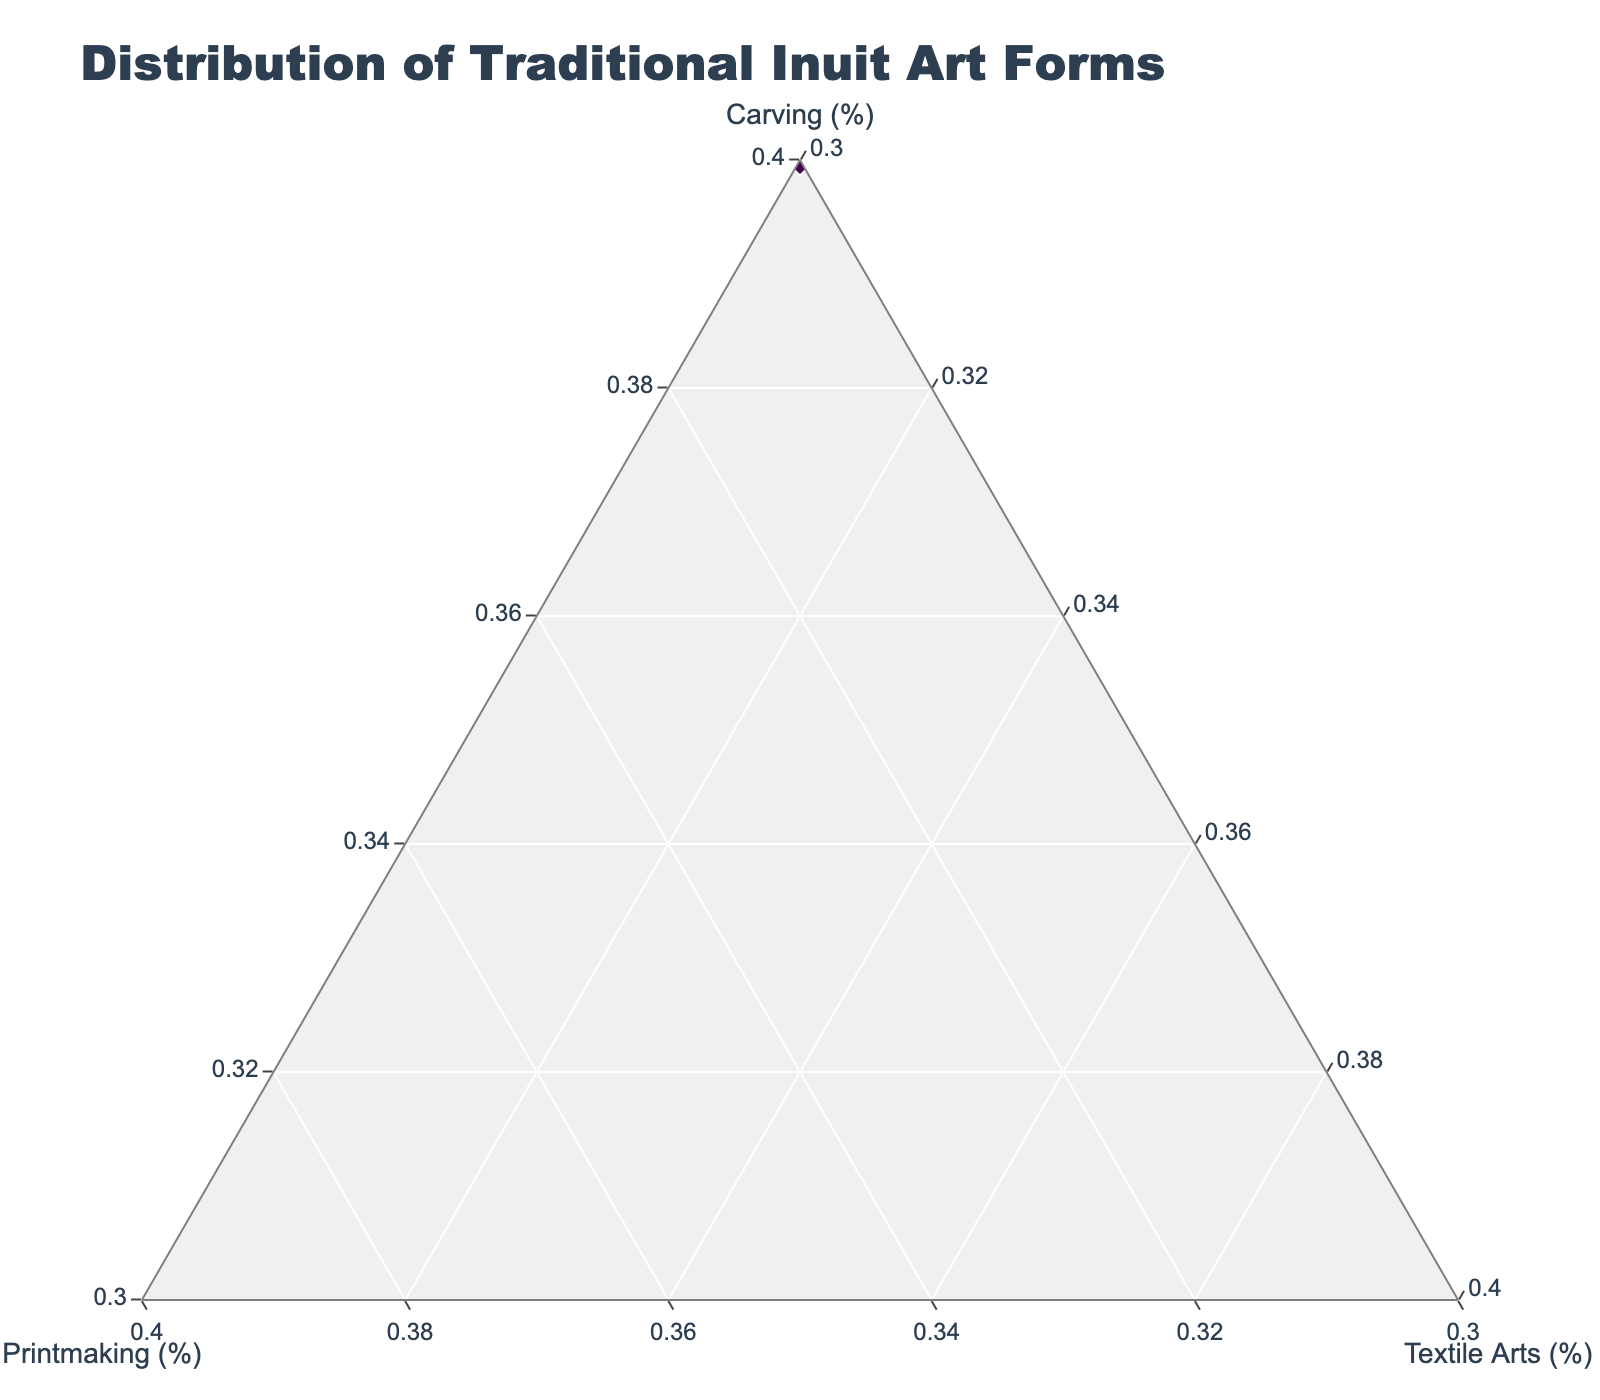What is the title of the figure? The title is usually displayed at the top of the plot and provides a brief description of what the figure represents. Here, it tells us the overall subject of the data showcased in the ternary plot.
Answer: Distribution of Traditional Inuit Art Forms Which region has the highest percentage of Carving? By analyzing the 'Carving (%)' axis, we look for the data point that reaches the highest value. The region associated with this point is the answer.
Answer: Qikiqtaaluk How many regions have more than 50% in Carving? We identify each region that has a carving percentage greater than 50%. By counting these regions, we get our answer.
Answer: 6 What is the median value for Printmaking across all regions? To find the median, arrange the printmaking values in ascending order: [10, 15, 15, 15, 20, 20, 25, 25, 30, 30, 35, 40]. The median is the average of the 6th and 7th values. (20 + 25) / 2 = 22.5
Answer: 22.5 Which regions have an equal percentage of Textile Arts? We look for regions that have the same textile arts value. The regions with 30% are Inuvialuit, Kivalliq, Arctic Bay, and Rankin Inlet.
Answer: Inuvialuit, Kivalliq, Arctic Bay, and Rankin Inlet Which region shows the highest value for Printmaking? By inspecting the 'Printmaking (%)' axis, find the point with the highest percentage, then identify the region associated with this point.
Answer: Hudson Bay Are there any regions where the percentage of Carving and Textile Arts is equal? By comparing each region's carving and textile arts values, we identify if any region has the same percentage for both art forms. None match.
Answer: No What is the average percentage of Textile Arts across the regions? Sum the textile arts percentages and divide by the number of regions: (15 + 15 + 30 + 20 + 15 + 20 + 30 + 15 + 30 + 30 + 15 + 30) / 12 = 21.25
Answer: 21.25 Which region is closest to having an equal distribution among Carving, Printmaking, and Textile Arts? Look for the region where the values for all three categories are similar. Rankin Inlet has 40% Carving, 30% Printmaking, and 30% Textile Arts.
Answer: Rankin Inlet If Baffin Island increased their Textile Arts by 5% and decreased Carving by the same amount, would they have the highest Textile Arts percentage? After adjusting Baffin Island's Textile Arts to 20%, compare it to the highest current Textile Arts value, which is 30%. They still won't have the highest value.
Answer: No 